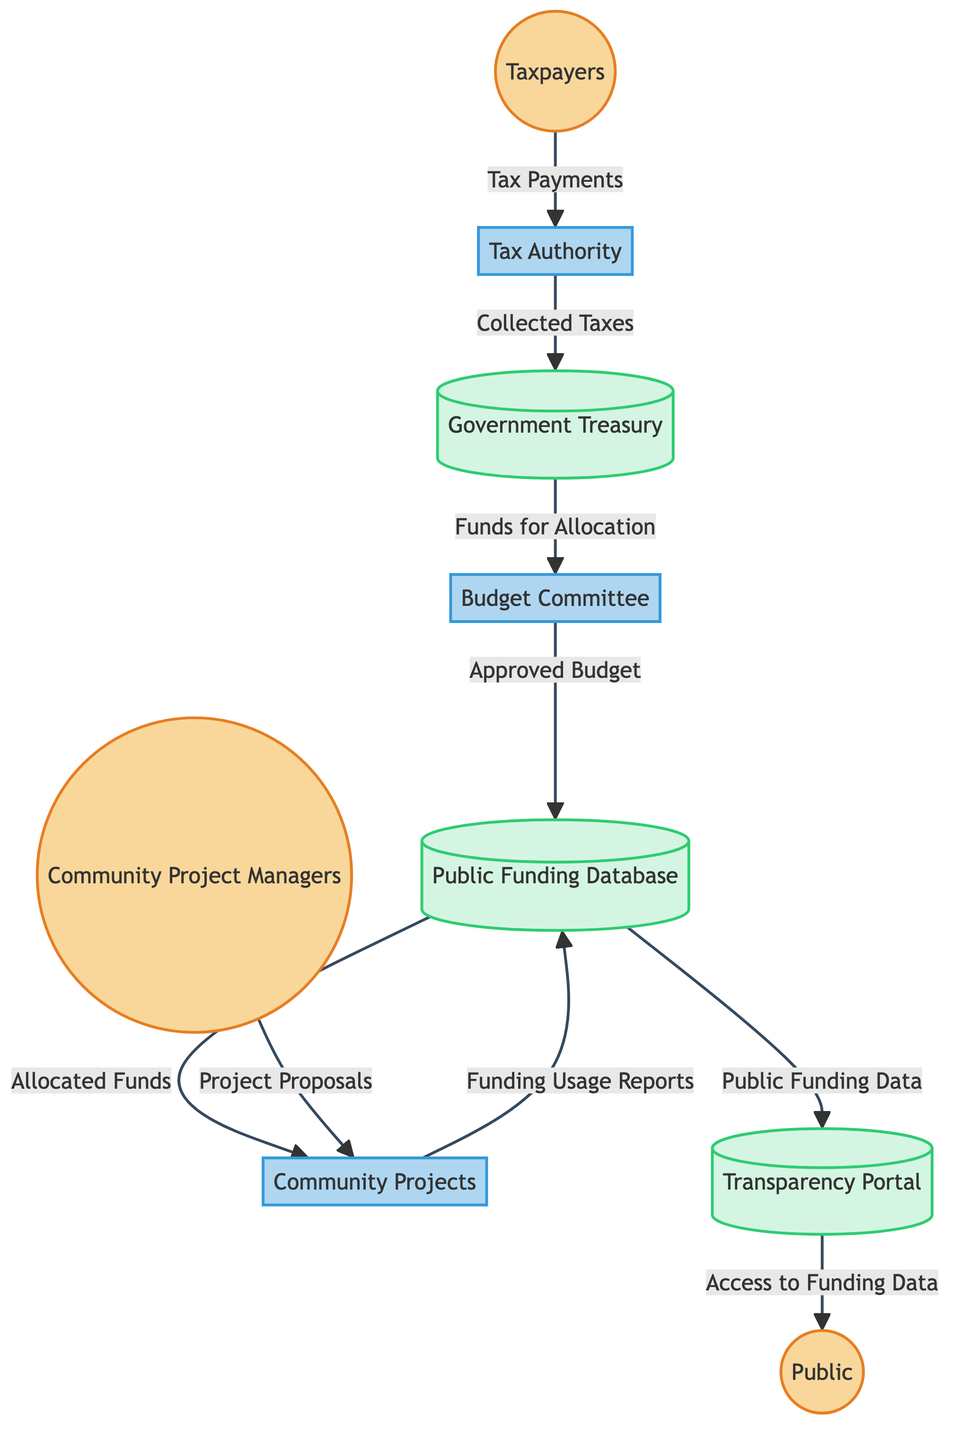What's the first node in the data flow? The first node in the data flow represented in the diagram is "Taxpayers". This can be identified as it is the starting point from which the flow originates.
Answer: Taxpayers How many processes are present in this diagram? The diagram has three processes: "Tax Authority," "Budget Committee," and "Community Projects." These entities perform specific actions within the data flow.
Answer: 3 What type of entity is "Government Treasury"? "Government Treasury" is categorized as a data store in the diagram. This can be determined from the visual classification of the entities based on their type.
Answer: Data Store What is the data flow from the "Budget Committee" to the "Public Funding Database"? The data flow from the "Budget Committee" to the "Public Funding Database" is labeled as "Approved Budget." This shows the specific information that moves between these two processes.
Answer: Approved Budget What do "Community Project Managers" provide to "Community Projects"? "Community Project Managers" provide "Project Proposals" to the "Community Projects." This is indicated by the directed data flow from one entity to the other in the diagram.
Answer: Project Proposals What type of entity is "Transparency Portal"? "Transparency Portal" is classified as a data store, as can be seen from its visual representation in the diagram, which highlights its role in storing information.
Answer: Data Store How many external entities are illustrated in the diagram? The diagram illustrates four external entities: "Taxpayers," "Community Project Managers," and "Public." Counting these entities provides the total number of external actors in the process.
Answer: 4 What is the final data output to the "Public" from the "Transparency Portal"? The final data output to the "Public" from the "Transparency Portal" is "Access to Funding Data." This flow indicates the end of the data journey in the diagram.
Answer: Access to Funding Data What is the connection between the "Community Projects" and the "Public Funding Database"? The connection between them is represented by "Funding Usage Reports," indicating how the Community Projects report back to the Public Funding Database regarding the utilization of funds.
Answer: Funding Usage Reports 